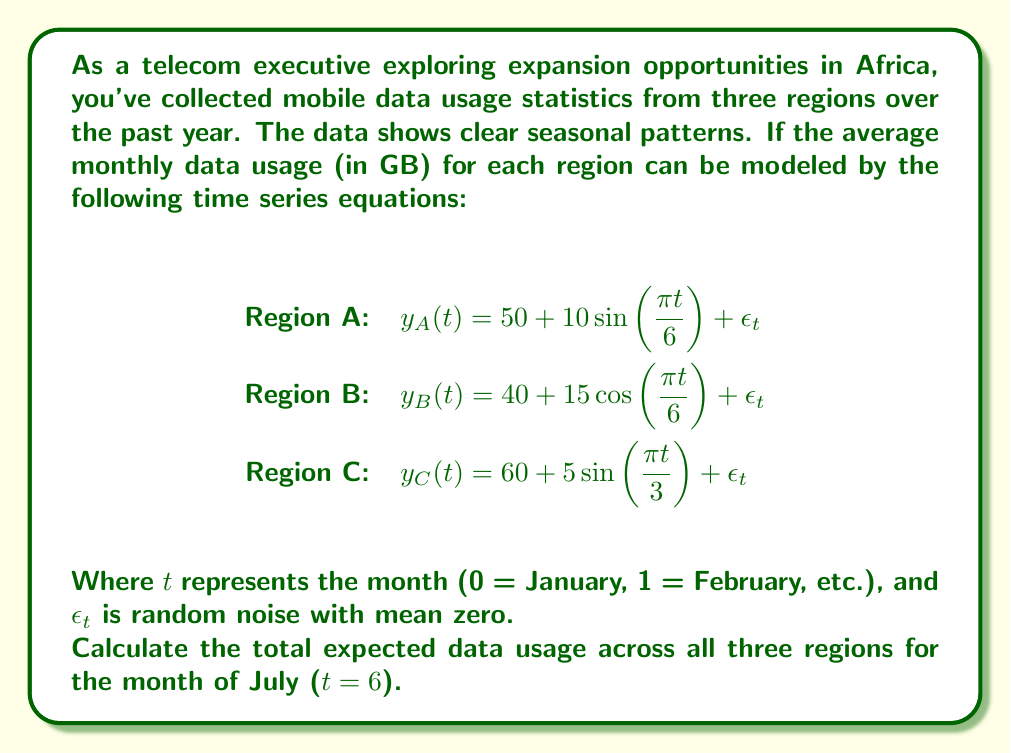Solve this math problem. To solve this problem, we need to follow these steps:

1. Identify the equation for each region's data usage.
2. Substitute t = 6 (July) into each equation.
3. Calculate the expected data usage for each region in July.
4. Sum the results to get the total expected data usage across all regions.

Let's go through each step:

1. We have the equations:
   Region A: $y_A(t) = 50 + 10\sin(\frac{\pi t}{6}) + \epsilon_t$
   Region B: $y_B(t) = 40 + 15\cos(\frac{\pi t}{6}) + \epsilon_t$
   Region C: $y_C(t) = 60 + 5\sin(\frac{\pi t}{3}) + \epsilon_t$

2. Substitute t = 6 into each equation:
   Region A: $y_A(6) = 50 + 10\sin(\frac{\pi 6}{6}) + \epsilon_6$
   Region B: $y_B(6) = 40 + 15\cos(\frac{\pi 6}{6}) + \epsilon_6$
   Region C: $y_C(6) = 60 + 5\sin(\frac{\pi 6}{3}) + \epsilon_6$

3. Calculate the expected data usage for each region:
   Region A: $y_A(6) = 50 + 10\sin(\pi) + \epsilon_6 = 50 + 0 + 0 = 50$ GB
   Region B: $y_B(6) = 40 + 15\cos(\pi) + \epsilon_6 = 40 - 15 + 0 = 25$ GB
   Region C: $y_C(6) = 60 + 5\sin(2\pi) + \epsilon_6 = 60 + 0 + 0 = 60$ GB

   Note: We set $\epsilon_6 = 0$ because it's the expected value (mean) of the random noise.

4. Sum the results:
   Total expected data usage = 50 + 25 + 60 = 135 GB

Therefore, the total expected data usage across all three regions for the month of July is 135 GB.
Answer: 135 GB 